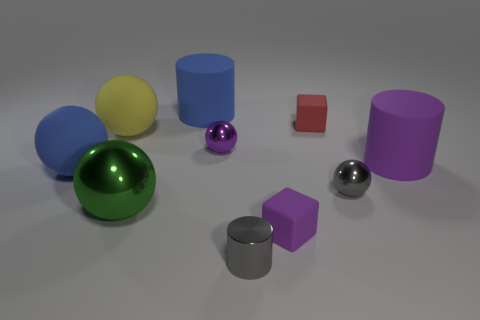Are there any tiny green matte balls?
Provide a succinct answer. No. There is a matte object in front of the small gray metallic thing on the right side of the gray metallic object that is in front of the large green metal ball; how big is it?
Make the answer very short. Small. How many green cylinders are made of the same material as the yellow thing?
Keep it short and to the point. 0. What number of red blocks are the same size as the purple metallic sphere?
Ensure brevity in your answer.  1. What material is the small cube that is behind the small cube in front of the matte thing that is on the right side of the red matte cube?
Make the answer very short. Rubber. What number of things are rubber cylinders or purple objects?
Give a very brief answer. 4. What shape is the small purple metal thing?
Provide a succinct answer. Sphere. There is a blue object that is right of the object that is on the left side of the yellow rubber ball; what is its shape?
Your answer should be very brief. Cylinder. Are the small object to the right of the red block and the big blue sphere made of the same material?
Provide a succinct answer. No. What number of blue objects are either large spheres or cubes?
Provide a succinct answer. 1. 